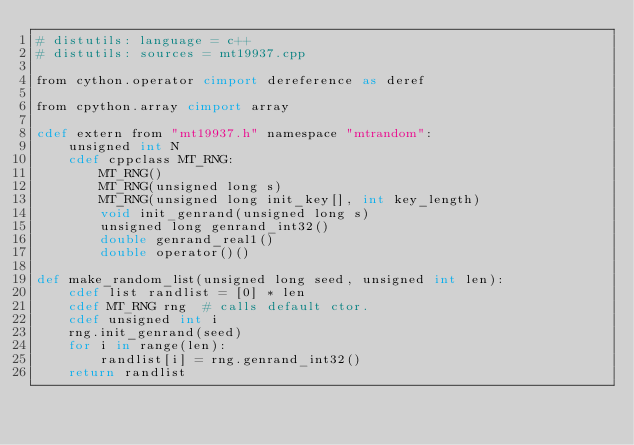<code> <loc_0><loc_0><loc_500><loc_500><_Cython_># distutils: language = c++
# distutils: sources = mt19937.cpp

from cython.operator cimport dereference as deref

from cpython.array cimport array

cdef extern from "mt19937.h" namespace "mtrandom":
    unsigned int N
    cdef cppclass MT_RNG:
        MT_RNG()
        MT_RNG(unsigned long s)
        MT_RNG(unsigned long init_key[], int key_length)
        void init_genrand(unsigned long s)
        unsigned long genrand_int32()
        double genrand_real1()
        double operator()()

def make_random_list(unsigned long seed, unsigned int len):
    cdef list randlist = [0] * len
    cdef MT_RNG rng  # calls default ctor.
    cdef unsigned int i
    rng.init_genrand(seed)
    for i in range(len):
        randlist[i] = rng.genrand_int32()
    return randlist
</code> 